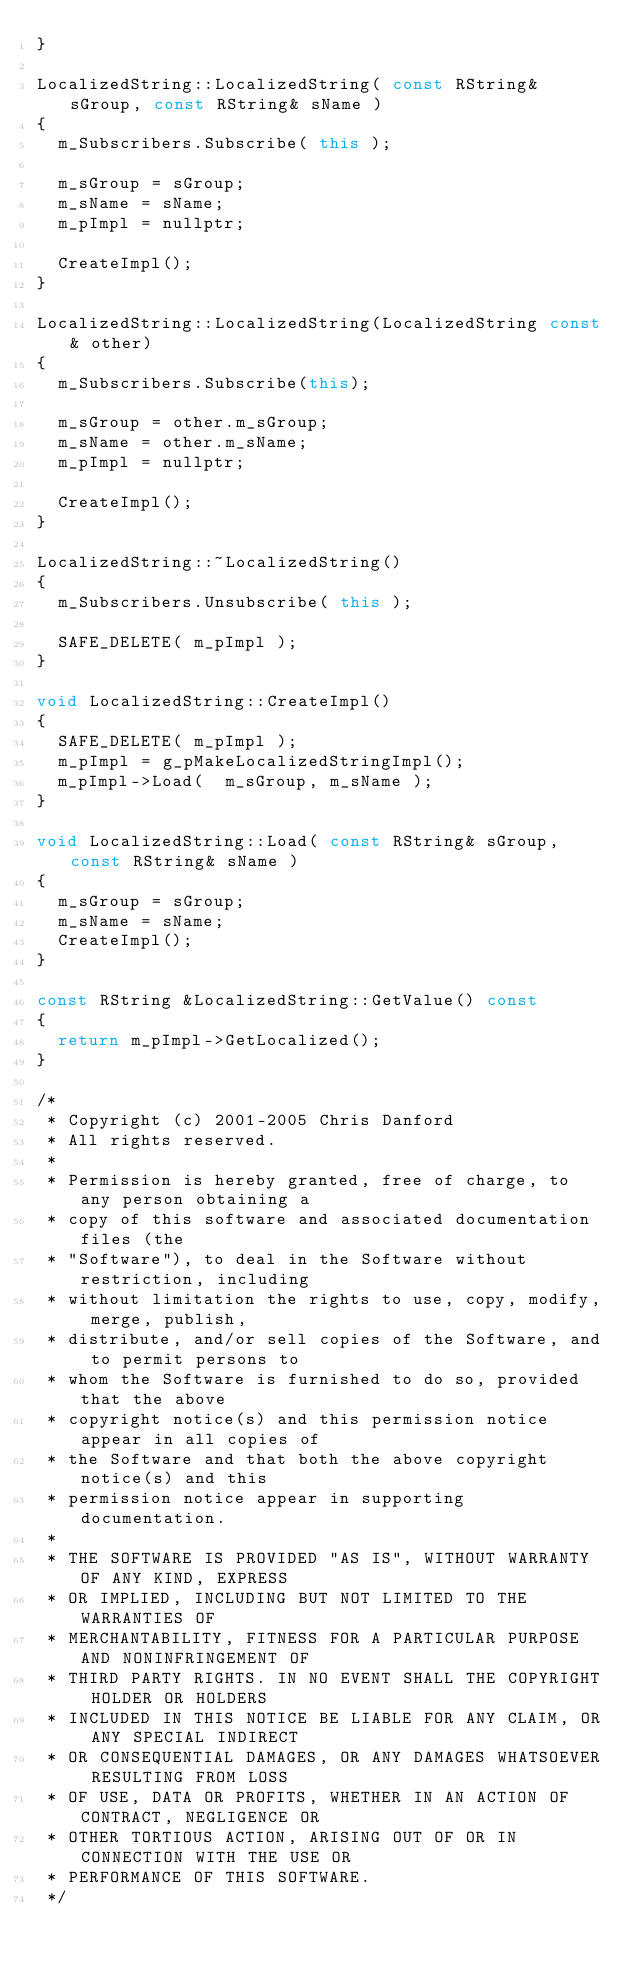Convert code to text. <code><loc_0><loc_0><loc_500><loc_500><_C++_>}

LocalizedString::LocalizedString( const RString& sGroup, const RString& sName )
{
	m_Subscribers.Subscribe( this );

	m_sGroup = sGroup;
	m_sName = sName;
	m_pImpl = nullptr;

	CreateImpl();
}

LocalizedString::LocalizedString(LocalizedString const& other)
{
	m_Subscribers.Subscribe(this);

	m_sGroup = other.m_sGroup;
	m_sName = other.m_sName;
	m_pImpl = nullptr;

	CreateImpl();
}

LocalizedString::~LocalizedString()
{
	m_Subscribers.Unsubscribe( this );

	SAFE_DELETE( m_pImpl );
}

void LocalizedString::CreateImpl()
{
	SAFE_DELETE( m_pImpl );
	m_pImpl = g_pMakeLocalizedStringImpl();
	m_pImpl->Load(  m_sGroup, m_sName );
}

void LocalizedString::Load( const RString& sGroup, const RString& sName )
{
	m_sGroup = sGroup;
	m_sName = sName;
	CreateImpl();
}

const RString &LocalizedString::GetValue() const
{
	return m_pImpl->GetLocalized();
}

/*
 * Copyright (c) 2001-2005 Chris Danford
 * All rights reserved.
 *
 * Permission is hereby granted, free of charge, to any person obtaining a
 * copy of this software and associated documentation files (the
 * "Software"), to deal in the Software without restriction, including
 * without limitation the rights to use, copy, modify, merge, publish,
 * distribute, and/or sell copies of the Software, and to permit persons to
 * whom the Software is furnished to do so, provided that the above
 * copyright notice(s) and this permission notice appear in all copies of
 * the Software and that both the above copyright notice(s) and this
 * permission notice appear in supporting documentation.
 *
 * THE SOFTWARE IS PROVIDED "AS IS", WITHOUT WARRANTY OF ANY KIND, EXPRESS
 * OR IMPLIED, INCLUDING BUT NOT LIMITED TO THE WARRANTIES OF
 * MERCHANTABILITY, FITNESS FOR A PARTICULAR PURPOSE AND NONINFRINGEMENT OF
 * THIRD PARTY RIGHTS. IN NO EVENT SHALL THE COPYRIGHT HOLDER OR HOLDERS
 * INCLUDED IN THIS NOTICE BE LIABLE FOR ANY CLAIM, OR ANY SPECIAL INDIRECT
 * OR CONSEQUENTIAL DAMAGES, OR ANY DAMAGES WHATSOEVER RESULTING FROM LOSS
 * OF USE, DATA OR PROFITS, WHETHER IN AN ACTION OF CONTRACT, NEGLIGENCE OR
 * OTHER TORTIOUS ACTION, ARISING OUT OF OR IN CONNECTION WITH THE USE OR
 * PERFORMANCE OF THIS SOFTWARE.
 */
</code> 